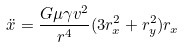<formula> <loc_0><loc_0><loc_500><loc_500>\ddot { x } = \frac { G \mu \gamma v ^ { 2 } } { r ^ { 4 } } ( 3 r _ { x } ^ { 2 } + r _ { y } ^ { 2 } ) r _ { x }</formula> 